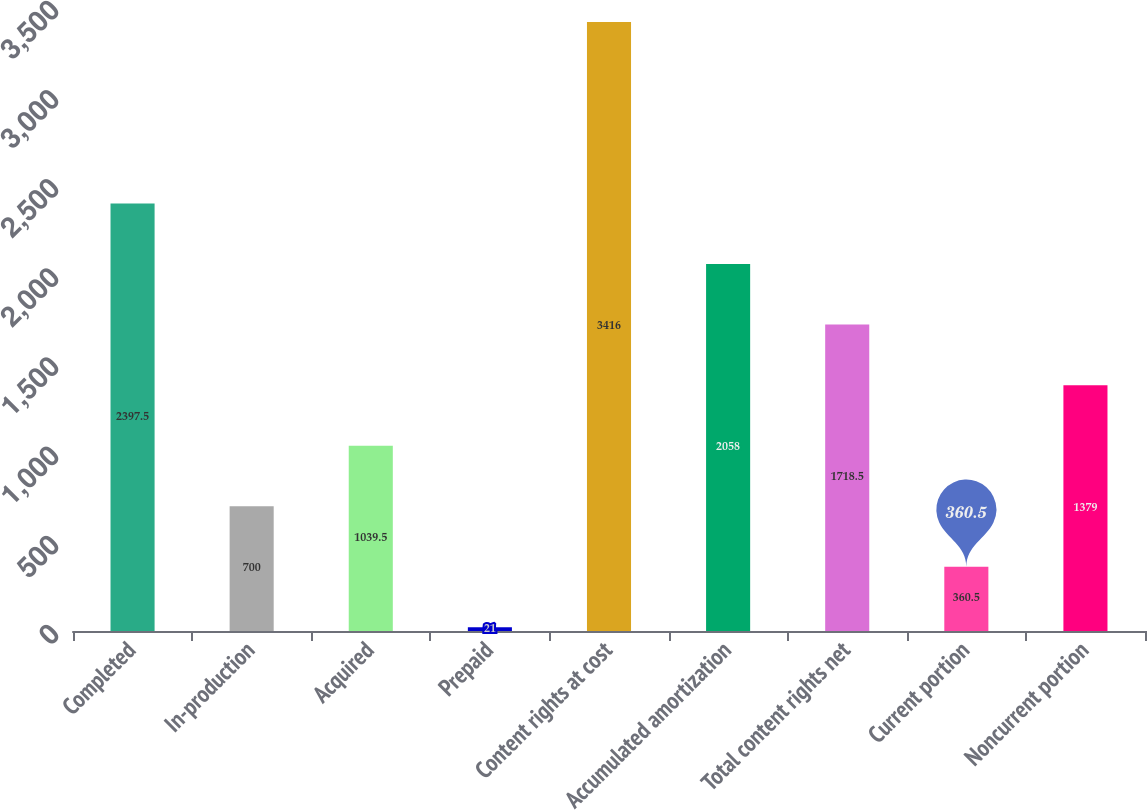Convert chart to OTSL. <chart><loc_0><loc_0><loc_500><loc_500><bar_chart><fcel>Completed<fcel>In-production<fcel>Acquired<fcel>Prepaid<fcel>Content rights at cost<fcel>Accumulated amortization<fcel>Total content rights net<fcel>Current portion<fcel>Noncurrent portion<nl><fcel>2397.5<fcel>700<fcel>1039.5<fcel>21<fcel>3416<fcel>2058<fcel>1718.5<fcel>360.5<fcel>1379<nl></chart> 